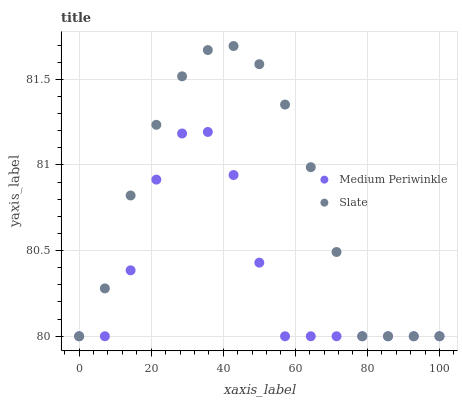Does Medium Periwinkle have the minimum area under the curve?
Answer yes or no. Yes. Does Slate have the maximum area under the curve?
Answer yes or no. Yes. Does Medium Periwinkle have the maximum area under the curve?
Answer yes or no. No. Is Slate the smoothest?
Answer yes or no. Yes. Is Medium Periwinkle the roughest?
Answer yes or no. Yes. Is Medium Periwinkle the smoothest?
Answer yes or no. No. Does Slate have the lowest value?
Answer yes or no. Yes. Does Slate have the highest value?
Answer yes or no. Yes. Does Medium Periwinkle have the highest value?
Answer yes or no. No. Does Slate intersect Medium Periwinkle?
Answer yes or no. Yes. Is Slate less than Medium Periwinkle?
Answer yes or no. No. Is Slate greater than Medium Periwinkle?
Answer yes or no. No. 